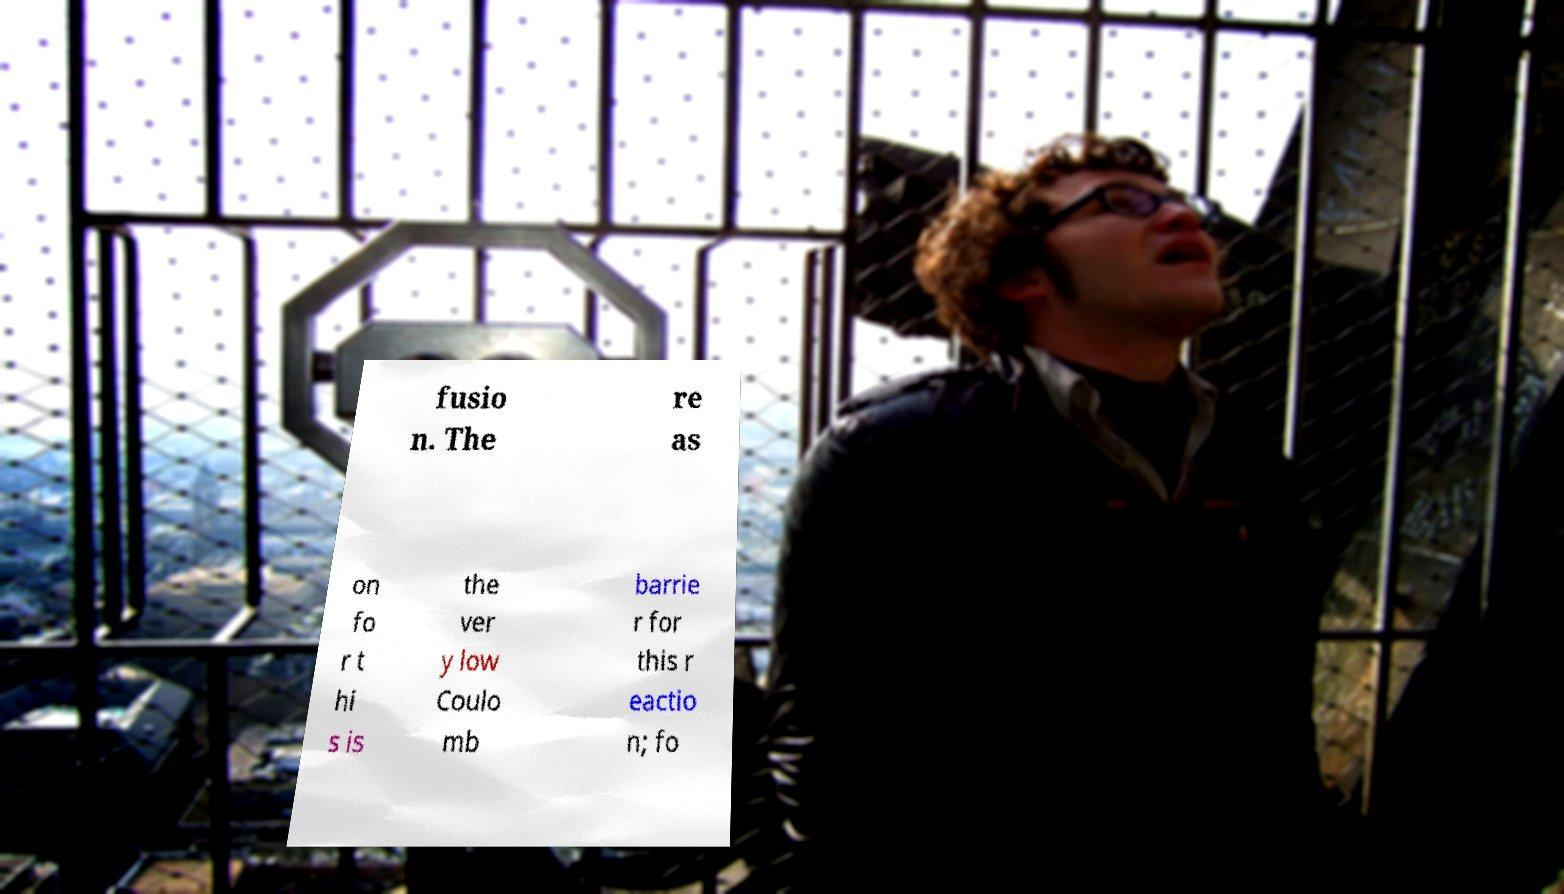I need the written content from this picture converted into text. Can you do that? fusio n. The re as on fo r t hi s is the ver y low Coulo mb barrie r for this r eactio n; fo 